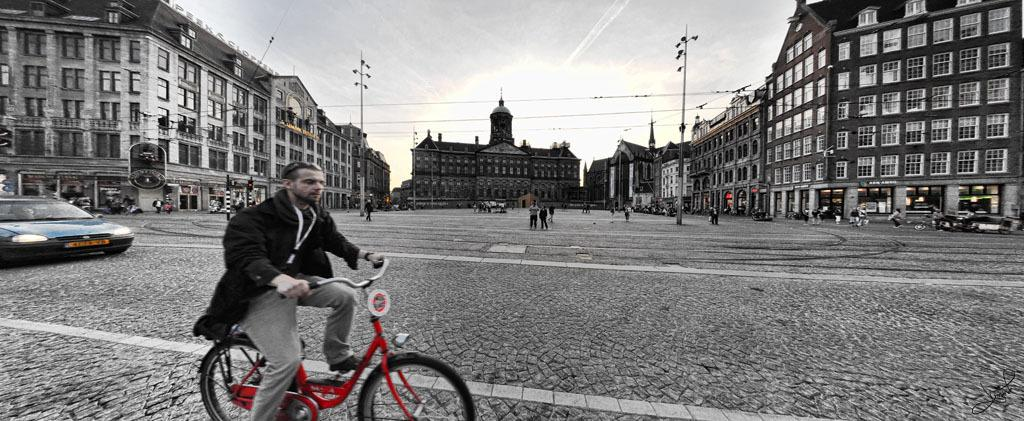What is the man in the image doing? The man is riding a bicycle on the road. What other vehicles or objects are present on the road? There is a car on the road. What can be seen in the background of the image? Buildings with windows, people standing and walking, a pole, and the sky are visible in the background. Can you tell me what type of example the man is setting for his father at the seashore in the image? There is no father or seashore present in the image; it features a man riding a bicycle on a road with other objects and people in the background. 